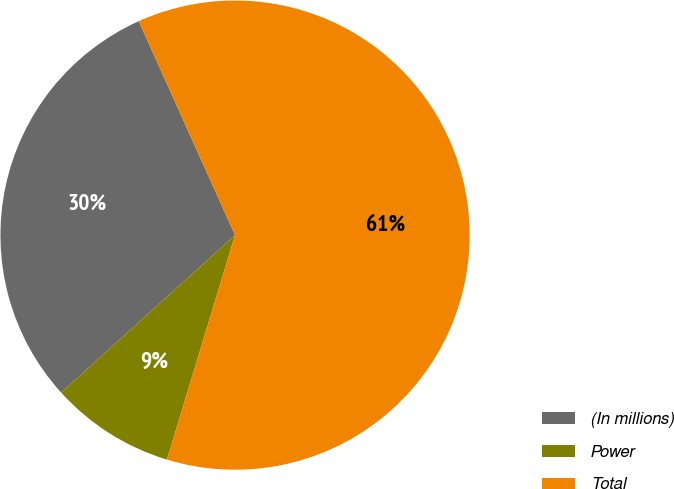Convert chart to OTSL. <chart><loc_0><loc_0><loc_500><loc_500><pie_chart><fcel>(In millions)<fcel>Power<fcel>Total<nl><fcel>29.98%<fcel>8.6%<fcel>61.42%<nl></chart> 